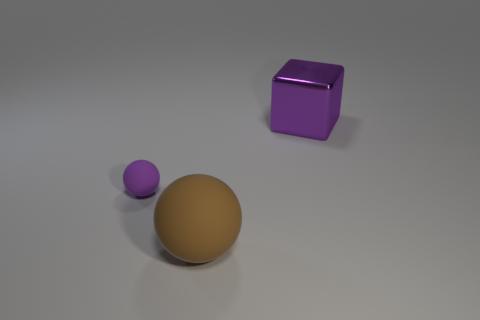Add 3 big red spheres. How many objects exist? 6 Subtract all cubes. How many objects are left? 2 Add 1 tiny things. How many tiny things exist? 2 Subtract 0 yellow cubes. How many objects are left? 3 Subtract all large purple objects. Subtract all purple shiny things. How many objects are left? 1 Add 3 purple cubes. How many purple cubes are left? 4 